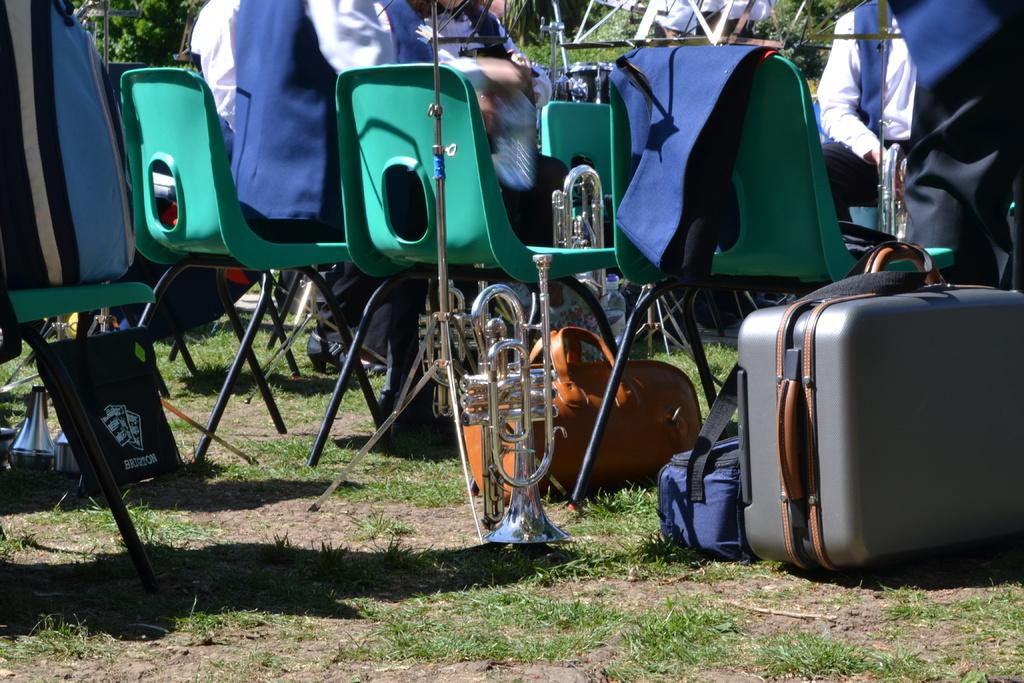How many people are in the image? There is a group of people in the image, but the exact number is not specified. What are the people doing in the image? The people are sitting on chairs in the image. What can be seen on the right side of the image? There is luggage, bags, and a musical instrument on the right side of the image. What type of surface is visible at the bottom of the image? There is grass visible at the bottom of the image. What type of box can be seen on the left side of the image? There is no box present on the left side of the image. How many weeks have passed since the event in the image occurred? The image does not provide any information about the timing of the event, so it is impossible to determine how many weeks have passed. 